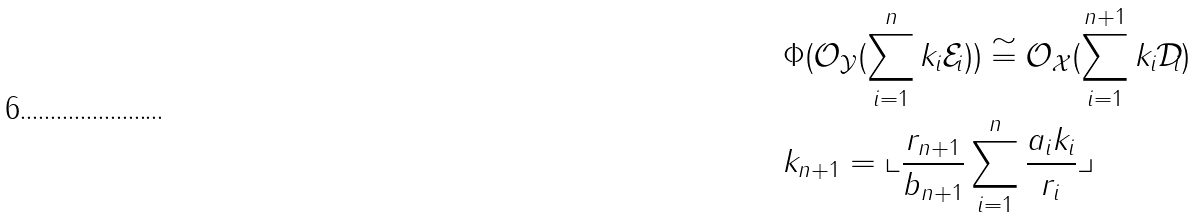Convert formula to latex. <formula><loc_0><loc_0><loc_500><loc_500>& \Phi ( \mathcal { O } _ { \mathcal { Y } } ( \sum _ { i = 1 } ^ { n } k _ { i } \mathcal { E } _ { i } ) ) \cong \mathcal { O } _ { \mathcal { X } } ( \sum _ { i = 1 } ^ { n + 1 } k _ { i } \mathcal { D } _ { i } ) \\ & k _ { n + 1 } = \llcorner \frac { r _ { n + 1 } } { b _ { n + 1 } } \sum _ { i = 1 } ^ { n } \frac { a _ { i } k _ { i } } { r _ { i } } \lrcorner</formula> 